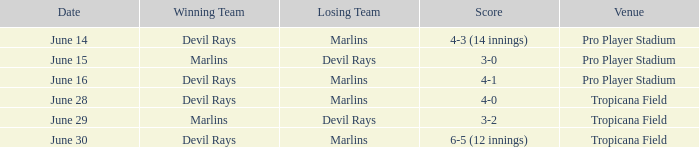What was the score on june 29 when the devil rays los? 3-2. 